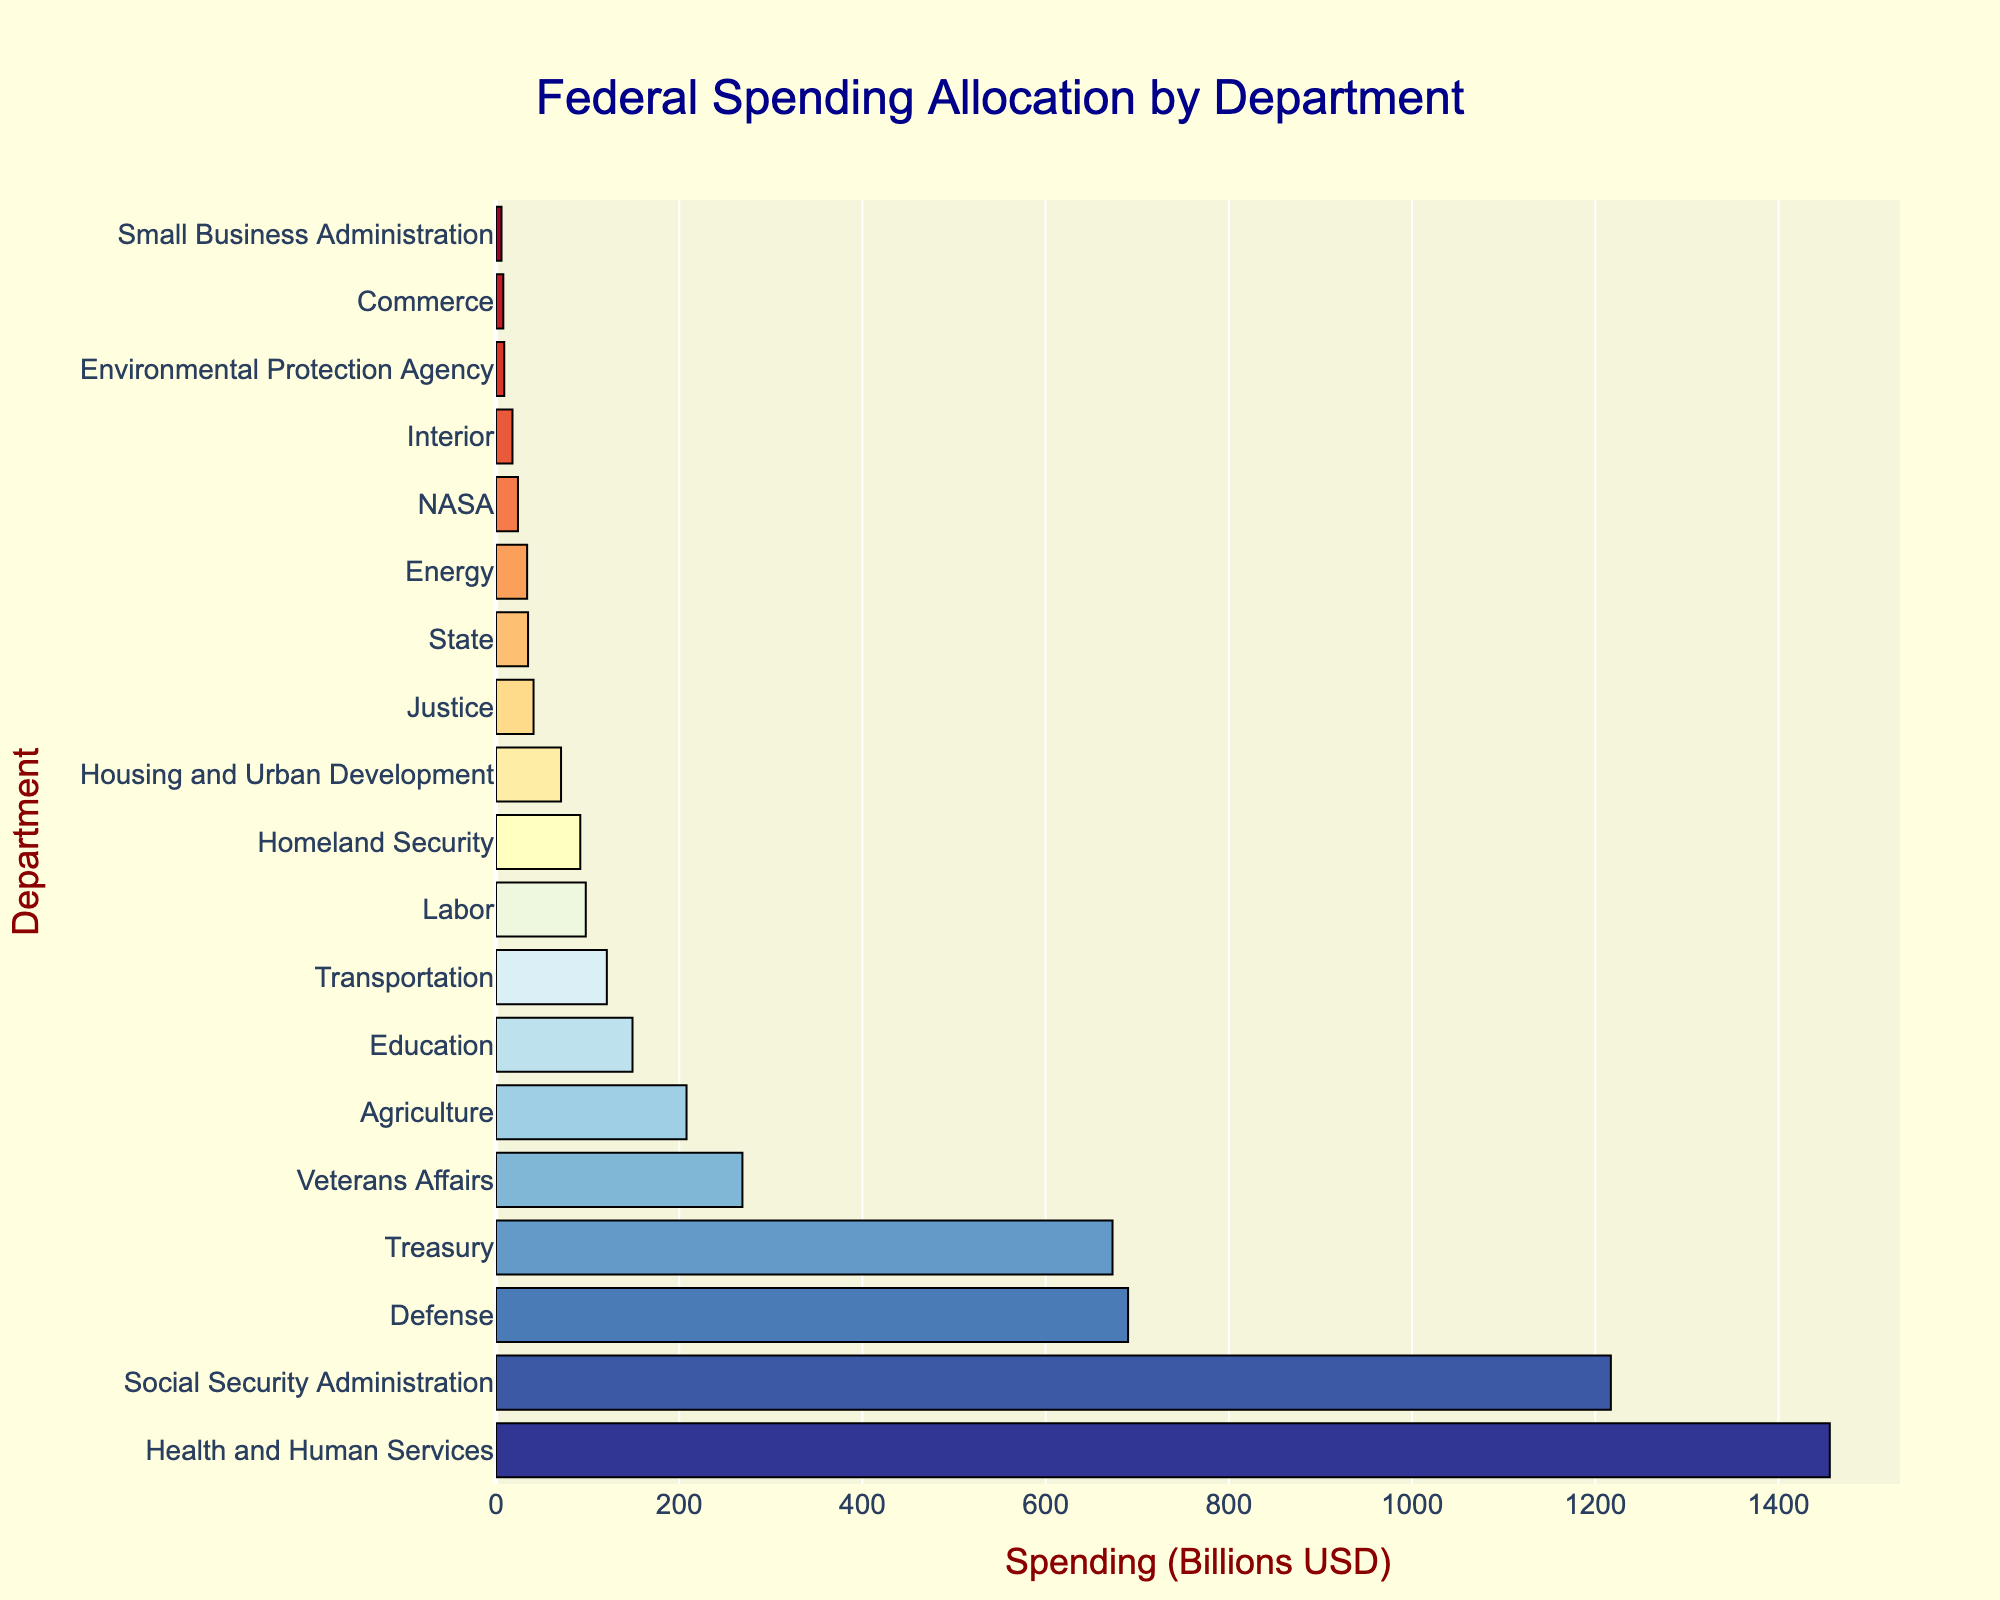Which department receives the most federal spending? The department with the longest bar represents the highest spending. The longest bar corresponds to Health and Human Services
Answer: Health and Human Services How much more is spent on Defense compared to Education? Look at the lengths of the bars for Defense and Education. Defense has $690 billion and Education has $149 billion. Subtract Education spending from Defense spending: $690 billion - $149 billion = $541 billion
Answer: $541 billion What is the total federal spending for the top three departments? The top three departments are Health and Human Services, Social Security Administration, and Defense. Sum their spending: $1456 billion + $1217 billion + $690 billion = $3363 billion
Answer: $3363 billion Which departments receive less than $50 billion in federal spending? Identify and list the departments with bars shorter than the $50 billion mark: State, Energy, NASA, Interior, Environmental Protection Agency, Commerce, and Small Business Administration
Answer: State, Energy, NASA, Interior, Environmental Protection Agency, Commerce, Small Business Administration What is the average federal spending for the Transportation, Labor, and Homeland Security departments? Sum the spending for these departments: $121 billion + $98 billion + $92 billion = $311 billion. Then, divide by the number of departments: $311 billion / 3 = approximately $103.67 billion
Answer: approximately $103.67 billion By how much does Treasury spending exceed that of Agriculture? Find the spending for Treasury ($673 billion) and Agriculture ($208 billion), then subtract Agriculture from Treasury: $673 billion - $208 billion = $465 billion
Answer: $465 billion What is the combined spending of the Justice and Interior departments? Add the spending for Justice ($41 billion) and Interior ($18 billion): $41 billion + $18 billion = $59 billion
Answer: $59 billion Which department has the least federal spending? The department with the shortest bar has the least spending. The shortest bar corresponds to the Small Business Administration
Answer: Small Business Administration 